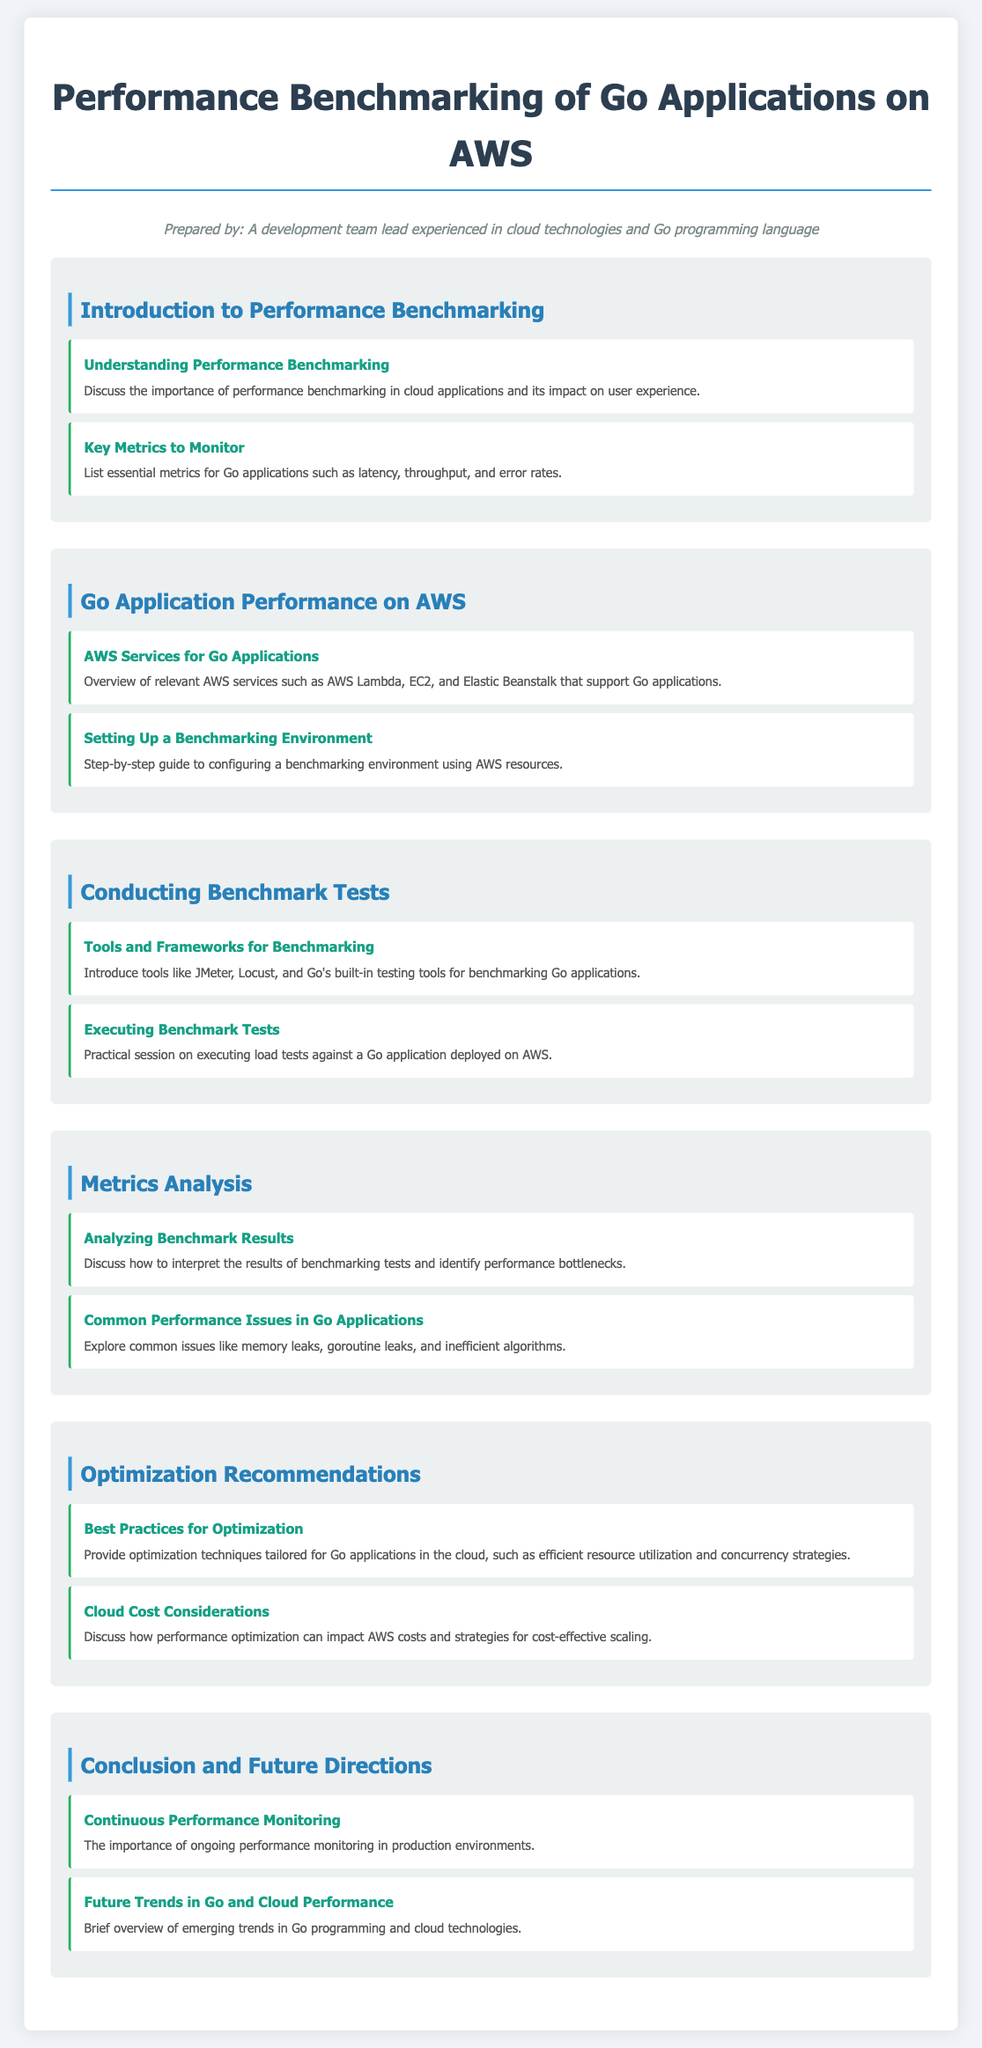What is the title of the document? The title of the document is prominently displayed at the top of the page.
Answer: Performance Benchmarking of Go Applications on AWS What is the first section in the document? The first section is labeled as the introductory part of the agenda discussing performance benchmarking.
Answer: Introduction to Performance Benchmarking How many key metrics are mentioned for Go applications? The document specifically highlights essential metrics to monitor in Go applications.
Answer: Three Which AWS services are discussed for Go applications? Relevant AWS services for Go applications are mentioned in the categorized section about AWS.
Answer: AWS Lambda, EC2, Elastic Beanstalk What tools are suggested for benchmarking Go applications? Tools for benchmarking are introduced in the section dedicated to conducting benchmark tests.
Answer: JMeter, Locust, Go's built-in testing tools What is a common performance issue in Go applications? A specific common performance issue is mentioned that may occur in Go applications.
Answer: Memory leaks What best practice for optimization is recommended? Techniques for optimization tailored for Go applications are suggested in the optimization recommendations section.
Answer: Efficient resource utilization What does continuous performance monitoring emphasize? The importance of ongoing performance monitoring is highlighted in the conclusion section.
Answer: Importance What does the document say about future trends? Future trends related to Go programming and cloud technologies are briefly overviewed.
Answer: Emerging trends 